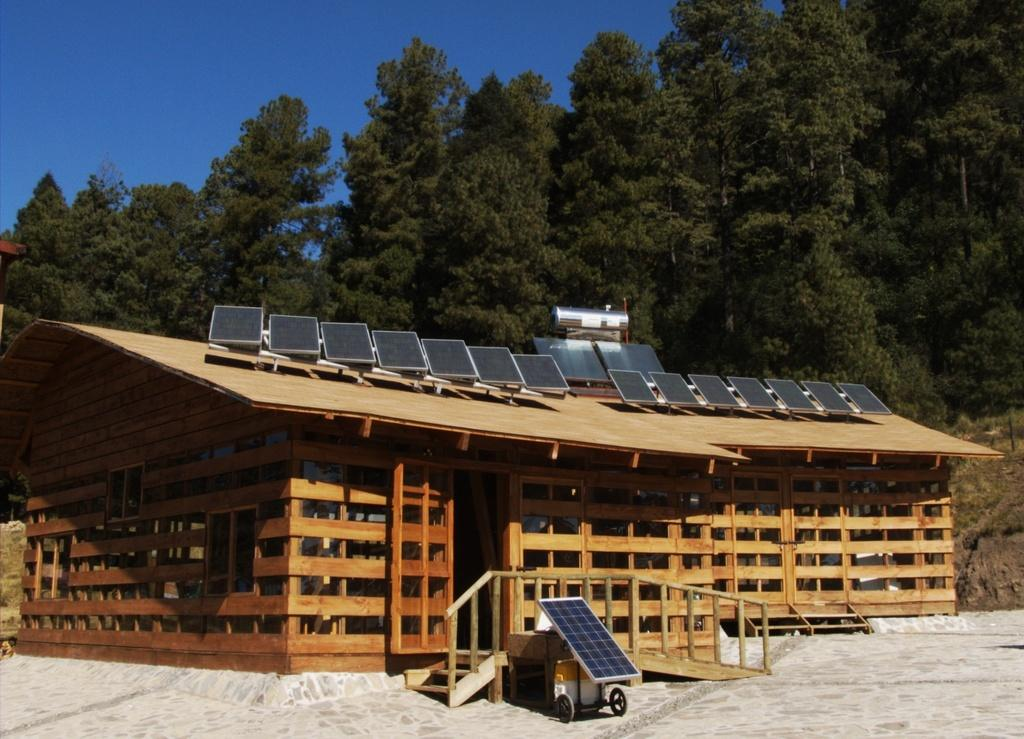What type of house is in the image? There is a wooden house in the image. What can be seen on the wooden house? There are objects on the wooden house. What is visible in the background of the image? There are trees and the sky visible in the background of the image. What architectural feature is present in the image? There are steps in the image. What else is present on the ground in the image? There is at least one other object on the ground. What type of kettle is being used in the war depicted in the image? There is no war or kettle present in the image; it features a wooden house with objects on it, steps, and a background with trees and the sky. 